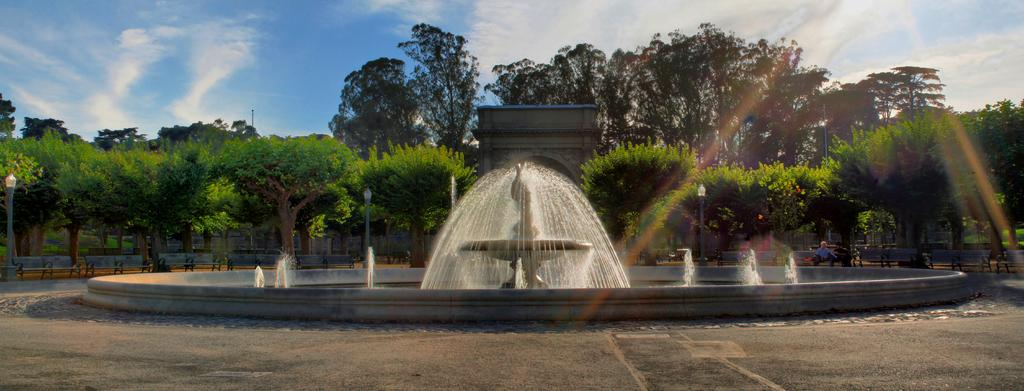What is the main feature in the middle of the image? There is a waterfall in the middle of the image. What can be seen behind the waterfall? Trees are present behind the waterfall. What is visible above the waterfall? The sky is visible above the waterfall. What can be observed in the sky? Clouds are present in the sky. What type of underwear is hanging on the trees behind the waterfall? There is no underwear present in the image; only the waterfall, trees, and sky are visible. 